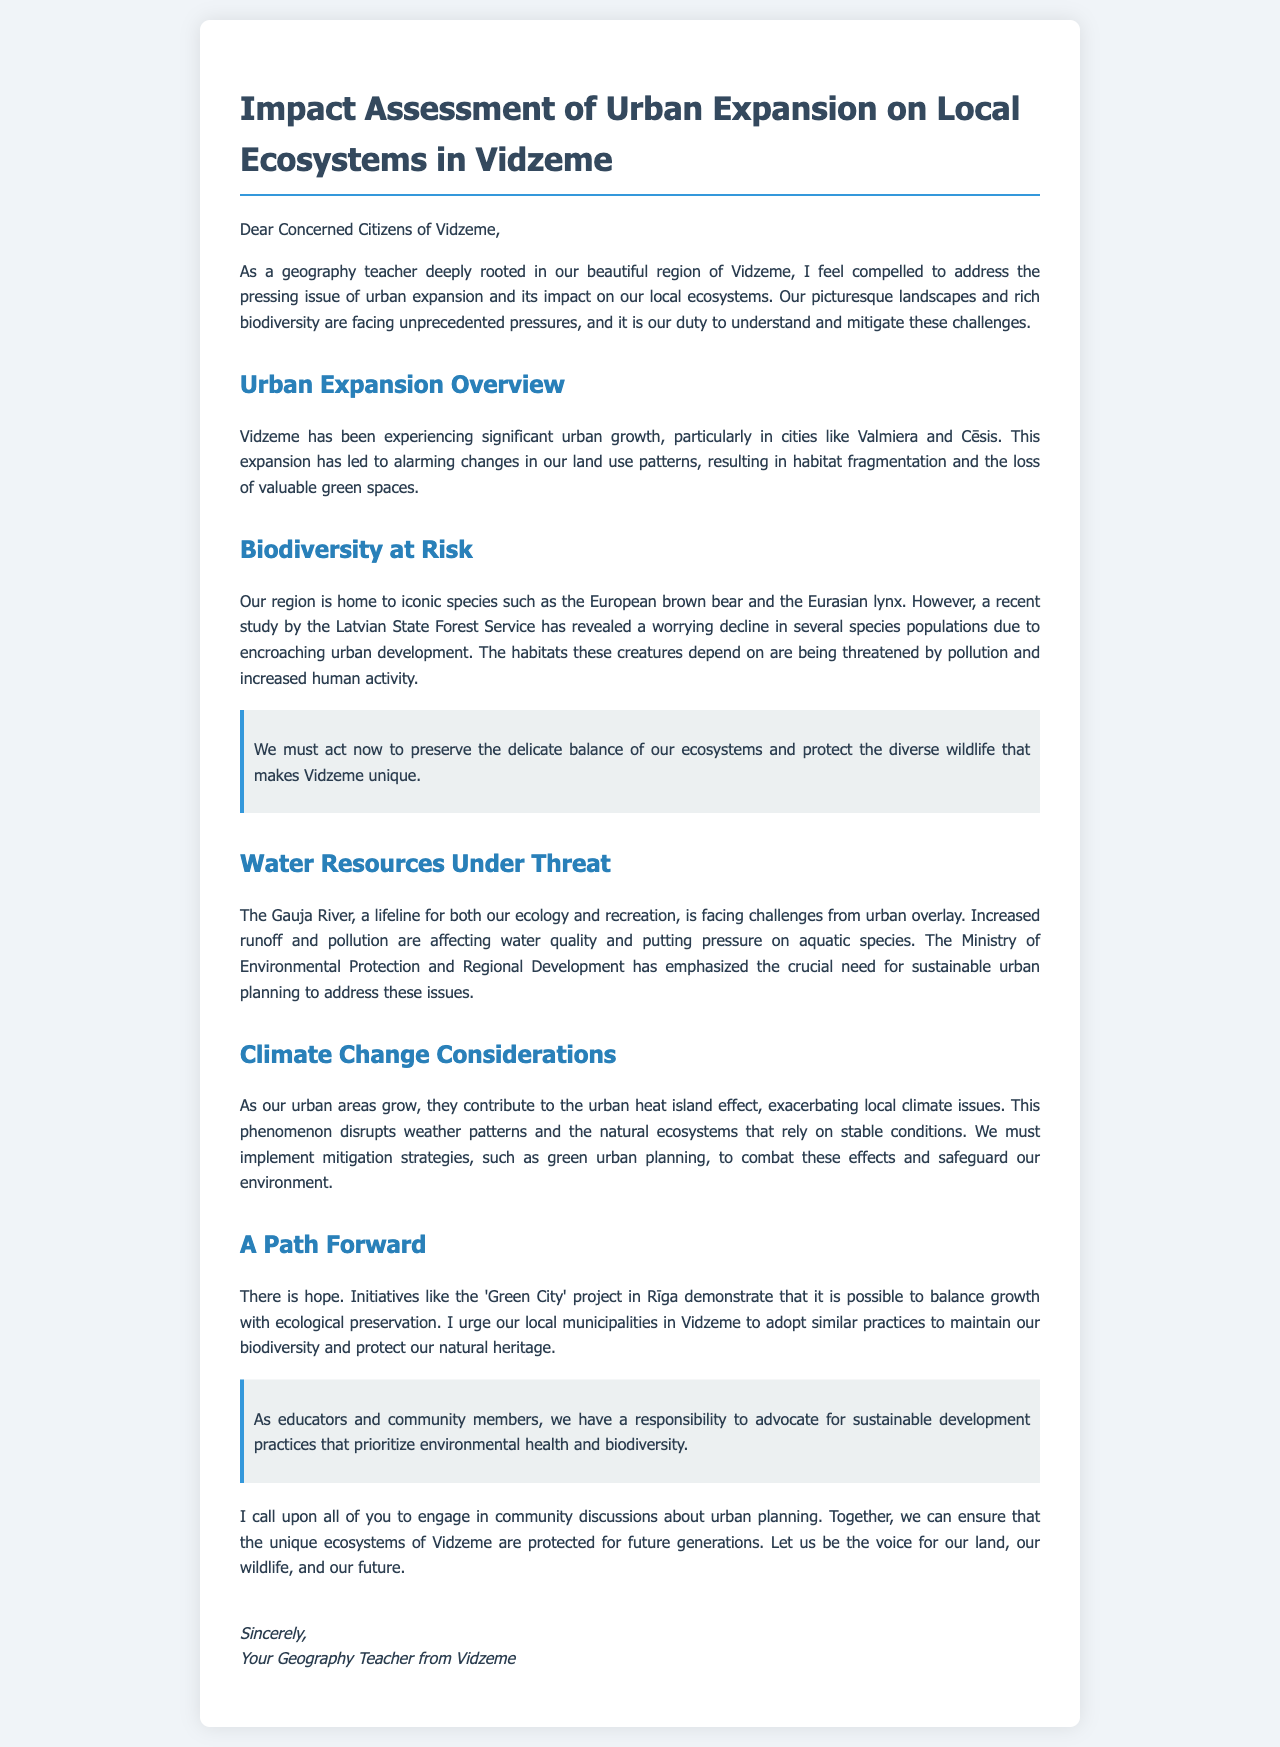What region is being discussed in the letter? The letter focuses on the region of Vidzeme, which is highlighted at the beginning.
Answer: Vidzeme What iconic species are mentioned in the document? The letter mentions two iconic species that are at risk, specifically identified in the biodiversity section.
Answer: European brown bear, Eurasian lynx What river is referred to as a lifeline for ecology in Vidzeme? The document refers to the Gauja River as crucial for both ecology and recreation.
Answer: Gauja River Which project is mentioned as a positive example of balancing growth and ecology? The letter references a specific project in Rīga that demonstrates ecological preservation amidst urban growth.
Answer: Green City How does urban expansion impact local ecosystems according to the document? The document states that urban growth leads to habitat fragmentation and loss of green spaces, addressing the consequences of urban expansion.
Answer: Habitat fragmentation, loss of green spaces What environmental issue does the urban heat island effect exacerbate? The letter discusses a specific climate-related issue that is worsened due to urban growth.
Answer: Local climate issues What is the publication's call to action for the local community? The letter encourages community engagement in discussions about urban planning aimed at protecting ecosystems.
Answer: Engage in community discussions What is the author's profession mentioned in the letter? The document indicates the author's profession, providing context to their perspective on the issues discussed.
Answer: Geography teacher 